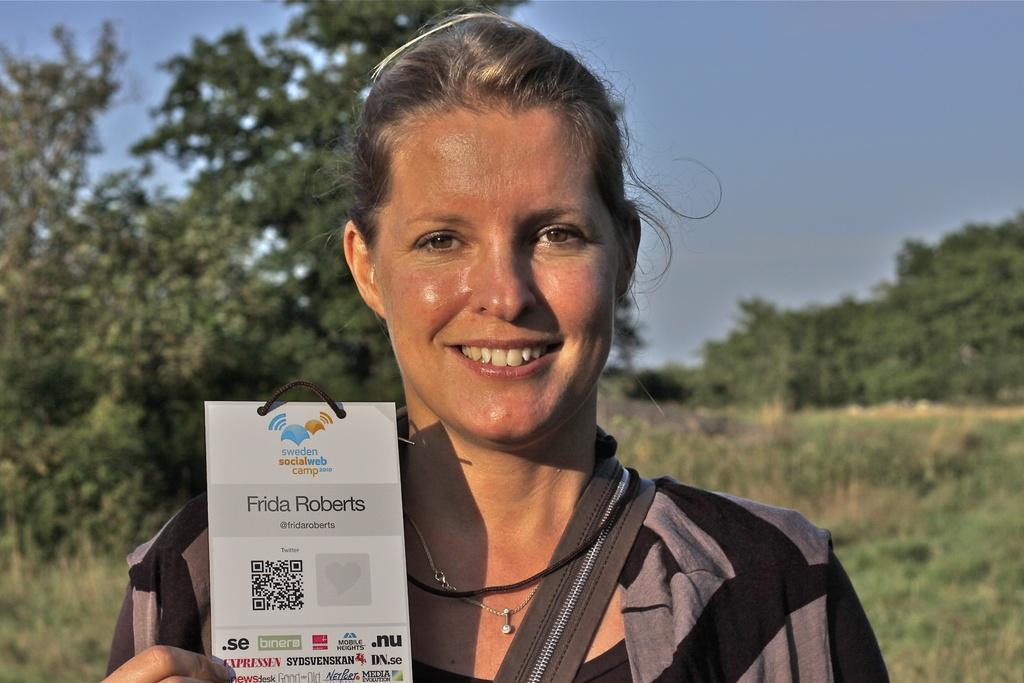Who is present in the image? There is a woman in the image. What is the woman doing in the image? The woman is smiling in the image. What is the woman holding in the image? The woman is holding a text card in the image. What can be seen in the background of the image? There are trees, grass, and the sky visible in the background of the image. What type of faucet can be seen in the image? There is no faucet present in the image. What color is the woman's chin in the image? The color of the woman's chin is not mentioned in the image, as the focus is on her smile and the text card she is holding. 